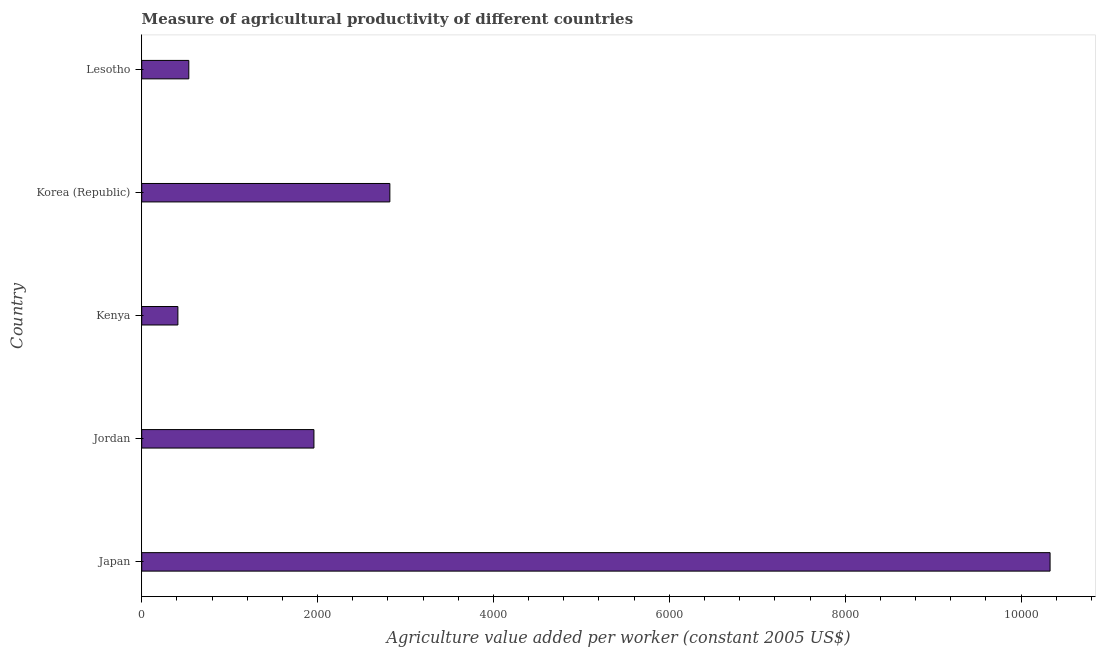Does the graph contain any zero values?
Your answer should be very brief. No. Does the graph contain grids?
Provide a short and direct response. No. What is the title of the graph?
Your response must be concise. Measure of agricultural productivity of different countries. What is the label or title of the X-axis?
Offer a terse response. Agriculture value added per worker (constant 2005 US$). What is the agriculture value added per worker in Korea (Republic)?
Your response must be concise. 2821.97. Across all countries, what is the maximum agriculture value added per worker?
Give a very brief answer. 1.03e+04. Across all countries, what is the minimum agriculture value added per worker?
Offer a very short reply. 411.31. In which country was the agriculture value added per worker minimum?
Give a very brief answer. Kenya. What is the sum of the agriculture value added per worker?
Your response must be concise. 1.61e+04. What is the difference between the agriculture value added per worker in Jordan and Korea (Republic)?
Keep it short and to the point. -863.52. What is the average agriculture value added per worker per country?
Your answer should be very brief. 3211.53. What is the median agriculture value added per worker?
Your answer should be very brief. 1958.45. What is the ratio of the agriculture value added per worker in Korea (Republic) to that in Lesotho?
Keep it short and to the point. 5.27. Is the agriculture value added per worker in Kenya less than that in Korea (Republic)?
Your answer should be compact. Yes. Is the difference between the agriculture value added per worker in Korea (Republic) and Lesotho greater than the difference between any two countries?
Provide a succinct answer. No. What is the difference between the highest and the second highest agriculture value added per worker?
Give a very brief answer. 7508.39. Is the sum of the agriculture value added per worker in Japan and Jordan greater than the maximum agriculture value added per worker across all countries?
Your response must be concise. Yes. What is the difference between the highest and the lowest agriculture value added per worker?
Provide a succinct answer. 9919.05. In how many countries, is the agriculture value added per worker greater than the average agriculture value added per worker taken over all countries?
Ensure brevity in your answer.  1. Are all the bars in the graph horizontal?
Make the answer very short. Yes. How many countries are there in the graph?
Your answer should be very brief. 5. What is the difference between two consecutive major ticks on the X-axis?
Provide a short and direct response. 2000. What is the Agriculture value added per worker (constant 2005 US$) of Japan?
Provide a succinct answer. 1.03e+04. What is the Agriculture value added per worker (constant 2005 US$) of Jordan?
Provide a short and direct response. 1958.45. What is the Agriculture value added per worker (constant 2005 US$) in Kenya?
Provide a succinct answer. 411.31. What is the Agriculture value added per worker (constant 2005 US$) in Korea (Republic)?
Your answer should be very brief. 2821.97. What is the Agriculture value added per worker (constant 2005 US$) in Lesotho?
Your answer should be compact. 535.53. What is the difference between the Agriculture value added per worker (constant 2005 US$) in Japan and Jordan?
Your answer should be very brief. 8371.91. What is the difference between the Agriculture value added per worker (constant 2005 US$) in Japan and Kenya?
Make the answer very short. 9919.05. What is the difference between the Agriculture value added per worker (constant 2005 US$) in Japan and Korea (Republic)?
Your answer should be very brief. 7508.39. What is the difference between the Agriculture value added per worker (constant 2005 US$) in Japan and Lesotho?
Your answer should be compact. 9794.84. What is the difference between the Agriculture value added per worker (constant 2005 US$) in Jordan and Kenya?
Keep it short and to the point. 1547.14. What is the difference between the Agriculture value added per worker (constant 2005 US$) in Jordan and Korea (Republic)?
Offer a terse response. -863.52. What is the difference between the Agriculture value added per worker (constant 2005 US$) in Jordan and Lesotho?
Provide a succinct answer. 1422.93. What is the difference between the Agriculture value added per worker (constant 2005 US$) in Kenya and Korea (Republic)?
Offer a terse response. -2410.66. What is the difference between the Agriculture value added per worker (constant 2005 US$) in Kenya and Lesotho?
Offer a very short reply. -124.22. What is the difference between the Agriculture value added per worker (constant 2005 US$) in Korea (Republic) and Lesotho?
Your response must be concise. 2286.45. What is the ratio of the Agriculture value added per worker (constant 2005 US$) in Japan to that in Jordan?
Provide a short and direct response. 5.28. What is the ratio of the Agriculture value added per worker (constant 2005 US$) in Japan to that in Kenya?
Offer a terse response. 25.12. What is the ratio of the Agriculture value added per worker (constant 2005 US$) in Japan to that in Korea (Republic)?
Make the answer very short. 3.66. What is the ratio of the Agriculture value added per worker (constant 2005 US$) in Japan to that in Lesotho?
Your response must be concise. 19.29. What is the ratio of the Agriculture value added per worker (constant 2005 US$) in Jordan to that in Kenya?
Give a very brief answer. 4.76. What is the ratio of the Agriculture value added per worker (constant 2005 US$) in Jordan to that in Korea (Republic)?
Keep it short and to the point. 0.69. What is the ratio of the Agriculture value added per worker (constant 2005 US$) in Jordan to that in Lesotho?
Ensure brevity in your answer.  3.66. What is the ratio of the Agriculture value added per worker (constant 2005 US$) in Kenya to that in Korea (Republic)?
Make the answer very short. 0.15. What is the ratio of the Agriculture value added per worker (constant 2005 US$) in Kenya to that in Lesotho?
Offer a terse response. 0.77. What is the ratio of the Agriculture value added per worker (constant 2005 US$) in Korea (Republic) to that in Lesotho?
Give a very brief answer. 5.27. 